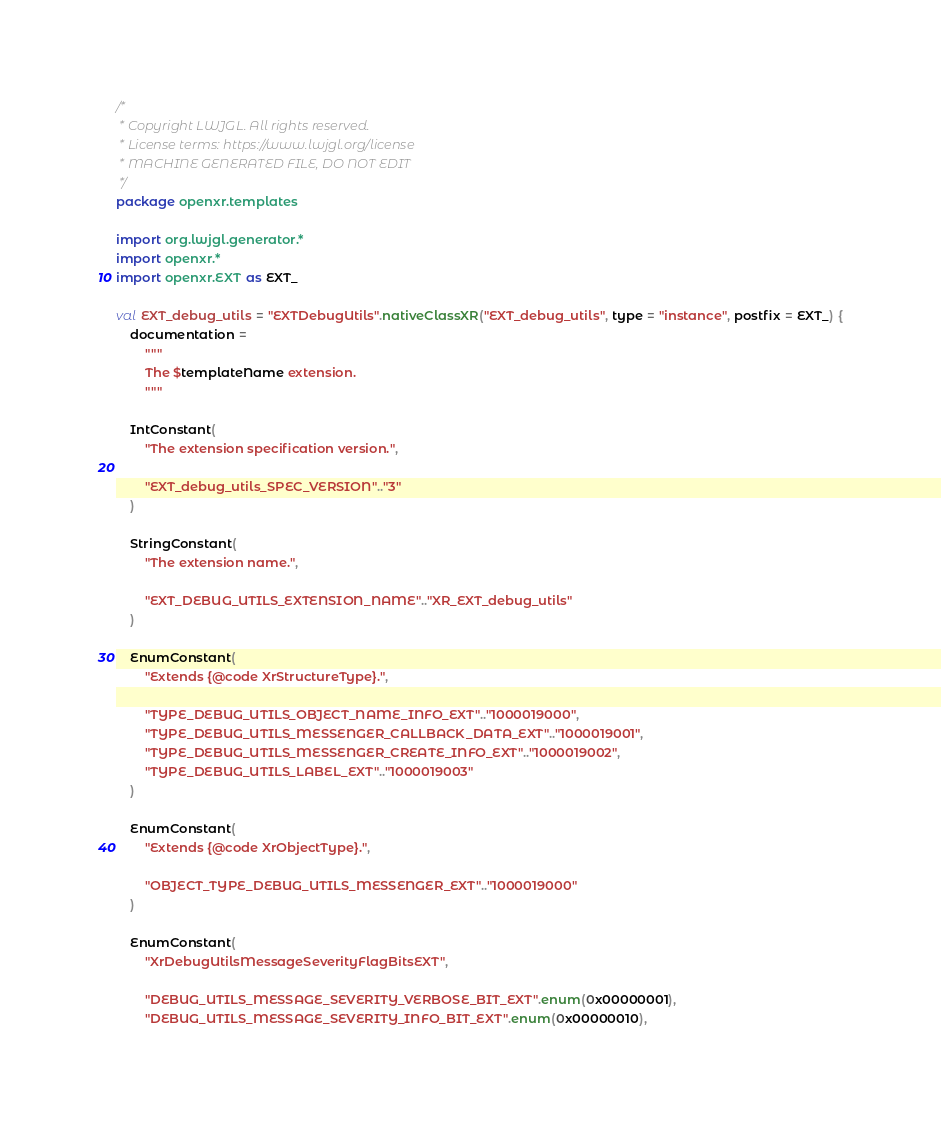Convert code to text. <code><loc_0><loc_0><loc_500><loc_500><_Kotlin_>/*
 * Copyright LWJGL. All rights reserved.
 * License terms: https://www.lwjgl.org/license
 * MACHINE GENERATED FILE, DO NOT EDIT
 */
package openxr.templates

import org.lwjgl.generator.*
import openxr.*
import openxr.EXT as EXT_

val EXT_debug_utils = "EXTDebugUtils".nativeClassXR("EXT_debug_utils", type = "instance", postfix = EXT_) {
    documentation =
        """
        The $templateName extension.
        """

    IntConstant(
        "The extension specification version.",

        "EXT_debug_utils_SPEC_VERSION".."3"
    )

    StringConstant(
        "The extension name.",

        "EXT_DEBUG_UTILS_EXTENSION_NAME".."XR_EXT_debug_utils"
    )

    EnumConstant(
        "Extends {@code XrStructureType}.",

        "TYPE_DEBUG_UTILS_OBJECT_NAME_INFO_EXT".."1000019000",
        "TYPE_DEBUG_UTILS_MESSENGER_CALLBACK_DATA_EXT".."1000019001",
        "TYPE_DEBUG_UTILS_MESSENGER_CREATE_INFO_EXT".."1000019002",
        "TYPE_DEBUG_UTILS_LABEL_EXT".."1000019003"
    )

    EnumConstant(
        "Extends {@code XrObjectType}.",

        "OBJECT_TYPE_DEBUG_UTILS_MESSENGER_EXT".."1000019000"
    )

    EnumConstant(
        "XrDebugUtilsMessageSeverityFlagBitsEXT",

        "DEBUG_UTILS_MESSAGE_SEVERITY_VERBOSE_BIT_EXT".enum(0x00000001),
        "DEBUG_UTILS_MESSAGE_SEVERITY_INFO_BIT_EXT".enum(0x00000010),</code> 